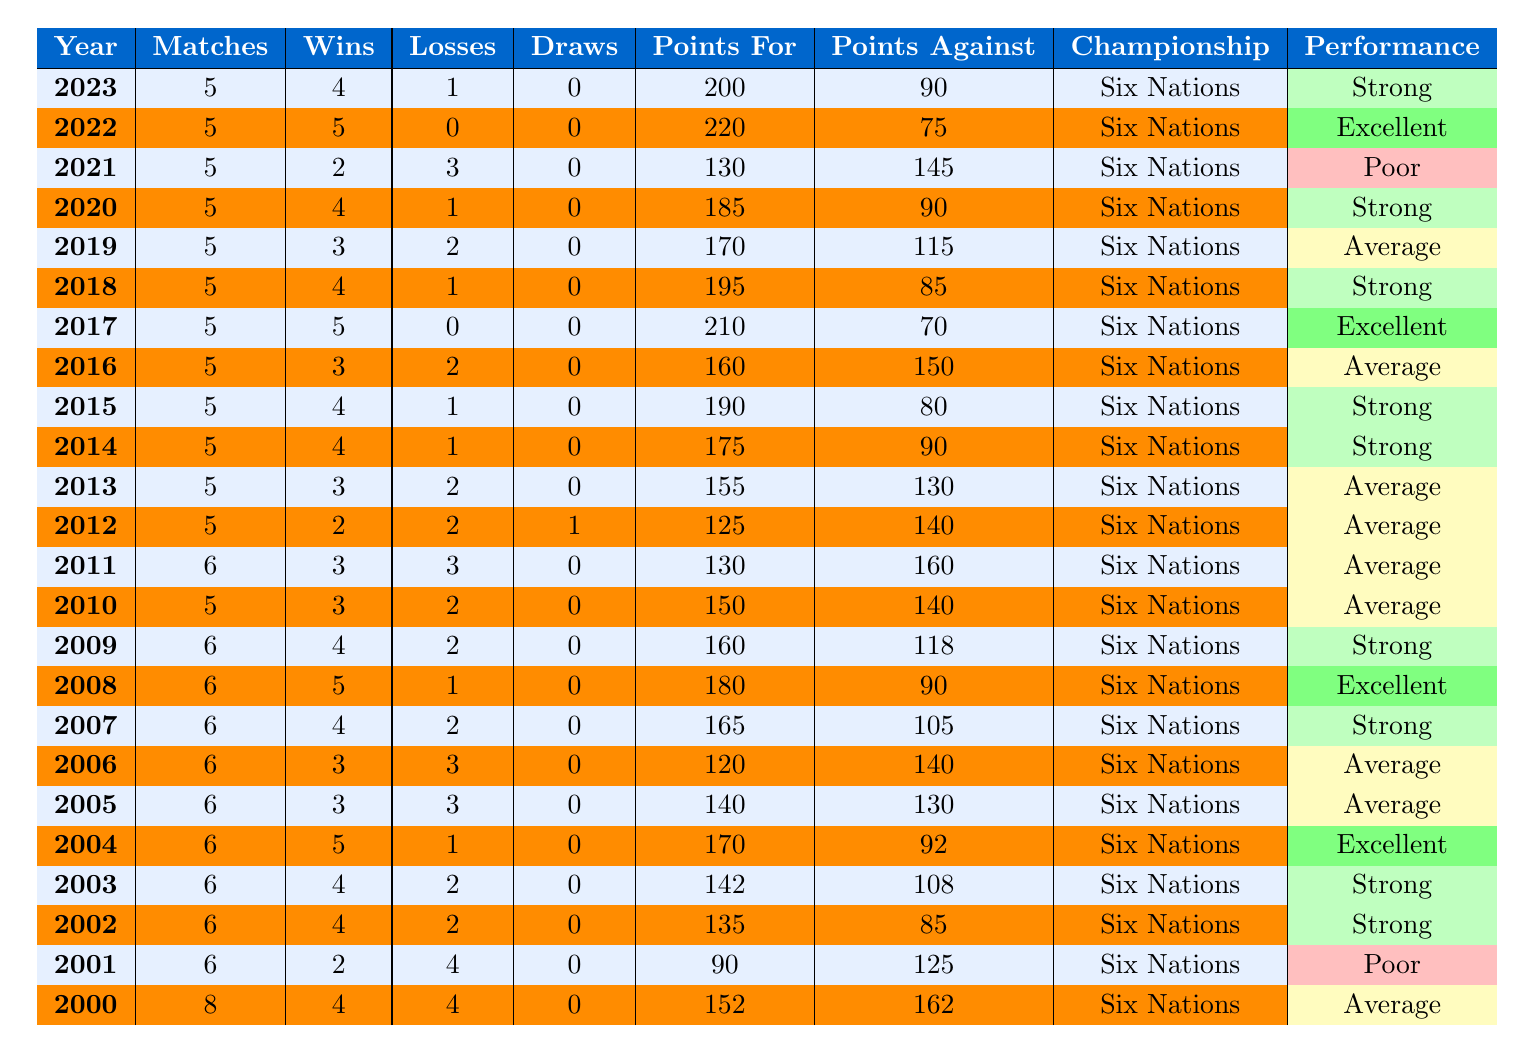What was Ireland's win-loss record in 2022? In 2022, Ireland played 5 matches, winning 5 and losing none, giving a win-loss record of 5-0.
Answer: 5-0 How many matches did Ireland play in total from 2000 to 2023? By summing the matches played from each year (8 + 6 + 6 + 6 + 6 + 6 + 6 + 6 + 6 + 5 + 6 + 5 + 5 + 5 + 5 + 5 + 5 + 5 + 5 + 5 + 5 + 5 = 118), the total matches played is 118.
Answer: 118 In which year did Ireland have the highest points for? The highest points for is shown in 2022 with 220 points.
Answer: 2022 What is the average number of wins per year for Ireland from 2000 to 2023? First, calculate the total wins from each year: (4 + 2 + 4 + 4 + 5 + 3 + 3 + 4 + 5 + 3 + 3 + 2 + 3 + 4 + 4 + 3 + 5 + 4 + 3 + 4 + 2 + 5 + 4 = 72). Then divide by the total number of years (24). The average is 72 / 24 = 3.
Answer: 3 Did Ireland ever record a perfect win in a championship year? Yes, in 2017 and 2022, Ireland recorded perfect wins with a record of 5-0 in both years.
Answer: Yes How many years did Ireland have a performance classified as "Poor"? The table shows that Ireland had a performance classified as "Poor" in the years 2001 and 2021, which totals to 2 years.
Answer: 2 Which year had the least number of wins and what was that number? The year with the least wins is 2001 with only 2 wins.
Answer: 2 What trends can be seen in Ireland's points against over the years? Reviewing the points against data, there are fluctuations but noticeable improvements in recent years, particularly in 2022 and 2017 where points against were significantly lower (75 and 70 respectively).
Answer: Improvement trend How many draws did Ireland have in the championships from 2000 to 2023? Ireland had only one draw recorded in the year 2012 out of all the championships played in that period.
Answer: 1 What is the performance classification for the year 2019? In 2019, Ireland's performance classification was shown as "Average" according to the table.
Answer: Average In which years did Ireland have an equal number of wins and losses? Ireland had equal numbers of wins and losses in the years 2006 (3-3) and 2011 (3-3).
Answer: 2006 and 2011 